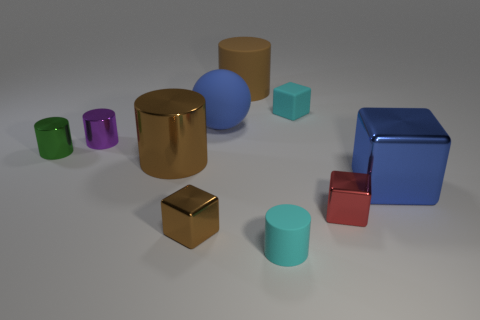Subtract all purple cylinders. How many cylinders are left? 4 Subtract all cyan cylinders. How many cylinders are left? 4 Subtract all red cylinders. Subtract all yellow cubes. How many cylinders are left? 5 Subtract all balls. How many objects are left? 9 Subtract 0 green balls. How many objects are left? 10 Subtract all small purple shiny blocks. Subtract all green things. How many objects are left? 9 Add 3 big objects. How many big objects are left? 7 Add 4 cyan matte things. How many cyan matte things exist? 6 